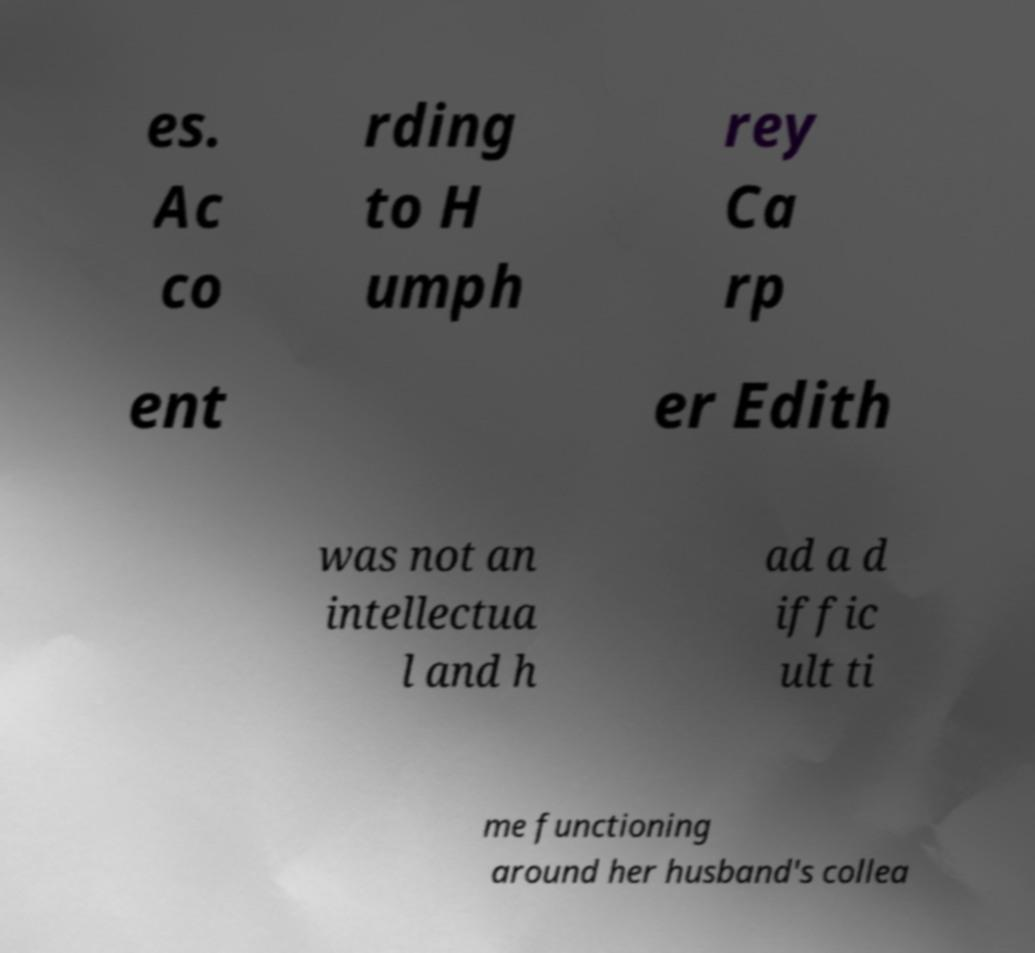Can you accurately transcribe the text from the provided image for me? es. Ac co rding to H umph rey Ca rp ent er Edith was not an intellectua l and h ad a d iffic ult ti me functioning around her husband's collea 